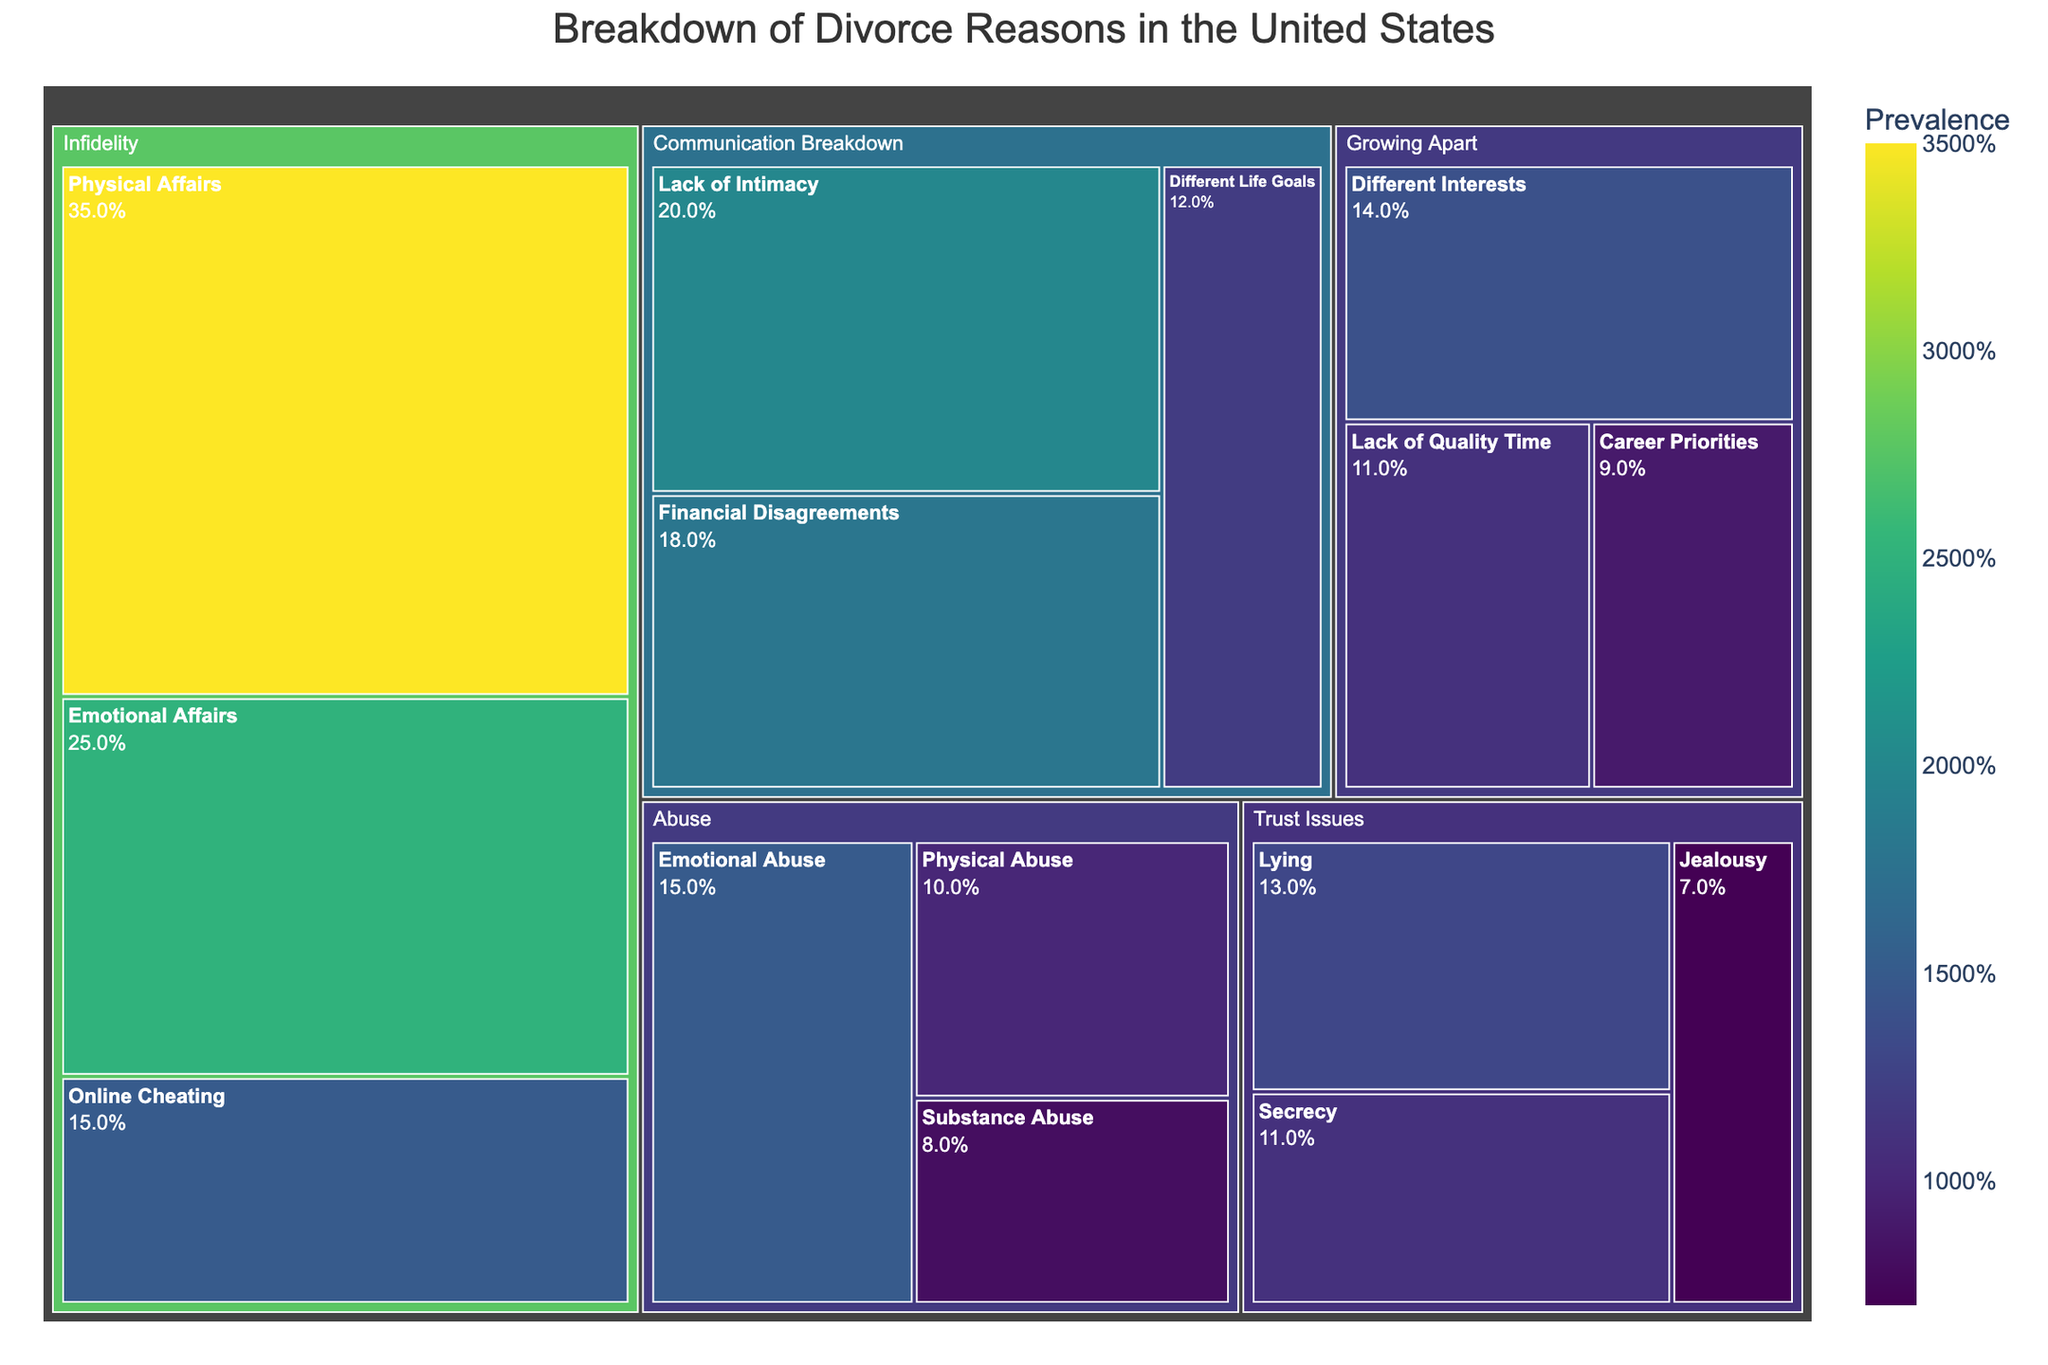What is the title of the treemap? The title of a figure can usually be found at the top. In this case, the title is clear and states the main focus of the visual representation.
Answer: Breakdown of Divorce Reasons in the United States Which subcategory has the highest value in the Infidelity category? Look at the subdivisions under the Infidelity category. Compare the values for 'Emotional Affairs', 'Physical Affairs', and 'Online Cheating'. 'Physical Affairs' has the highest value with 35.
Answer: Physical Affairs What is the total value for the category Infidelity? Add up the values of all subcategories under Infidelity: 25 (Emotional Affairs) + 35 (Physical Affairs) + 15 (Online Cheating) = 75.
Answer: 75 Which category has the largest total value? To find the category with the largest total value, compare the sum of values of all subcategories under each category. Calculate the sum for each and identify the largest:
- Infidelity: 75
- Communication Breakdown: 50
- Abuse: 33
- Growing Apart: 34
- Trust Issues: 31
Infidelity has the largest total value.
Answer: Infidelity Which subcategory has the lowest value, and in which main category is it located? Find the smallest value across all subcategories in the treemap, which is 'Substance Abuse' with a value of 8, under the main category Abuse.
Answer: Substance Abuse, Abuse What is the total value for the 'Abuse' category, and how does it compare to 'Growing Apart'? Add up the values for Abuse and Growing Apart:
- Abuse: 10 (Physical Abuse) + 15 (Emotional Abuse) + 8 (Substance Abuse) = 33.
- Growing Apart: 14 (Different Interests) + 11 (Lack of Quality Time) + 9 (Career Priorities) = 34.
Abuse has a total value of 33, which is 1 less than Growing Apart's total of 34.
Answer: Abuse: 33, Growing Apart: 34 What is the sum of values for the subcategories under Communication Breakdown? Add the values of all subcategories under Communication Breakdown: 20 (Lack of Intimacy) + 18 (Financial Disagreements) + 12 (Different Life Goals) = 50.
Answer: 50 Which main category has the most subcategories? Count the number of subcategories under each main category:
- Infidelity: 3
- Communication Breakdown: 3
- Abuse: 3
- Growing Apart: 3
- Trust Issues: 3
All main categories have an equal number of subcategories.
Answer: All have 3 Is the value of 'Lack of Quality Time' greater than, less than, or equal to 'Lack of Intimacy'? Compare the values of the two subcategories. 'Lack of Quality Time' has a value of 11, whereas 'Lack of Intimacy' has a value of 20. 11 is less than 20.
Answer: Less than What is the average value of all subcategories under the 'Trust Issues' category? Add the values of all subcategories under Trust Issues and divide by the number of subcategories:
(13 + 11 + 7) / 3 = 31 / 3 = 10.33.
Answer: 10.33 